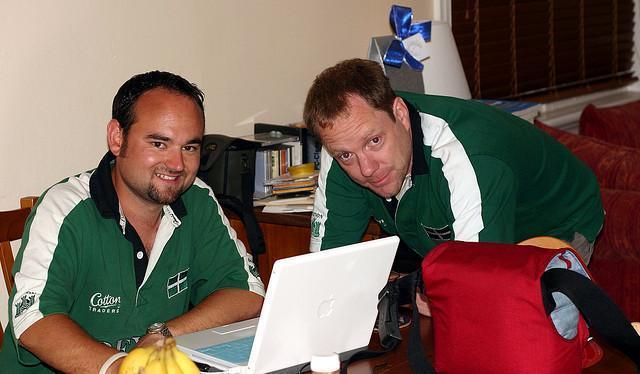How many handbags are there?
Give a very brief answer. 2. How many people can you see?
Give a very brief answer. 2. 